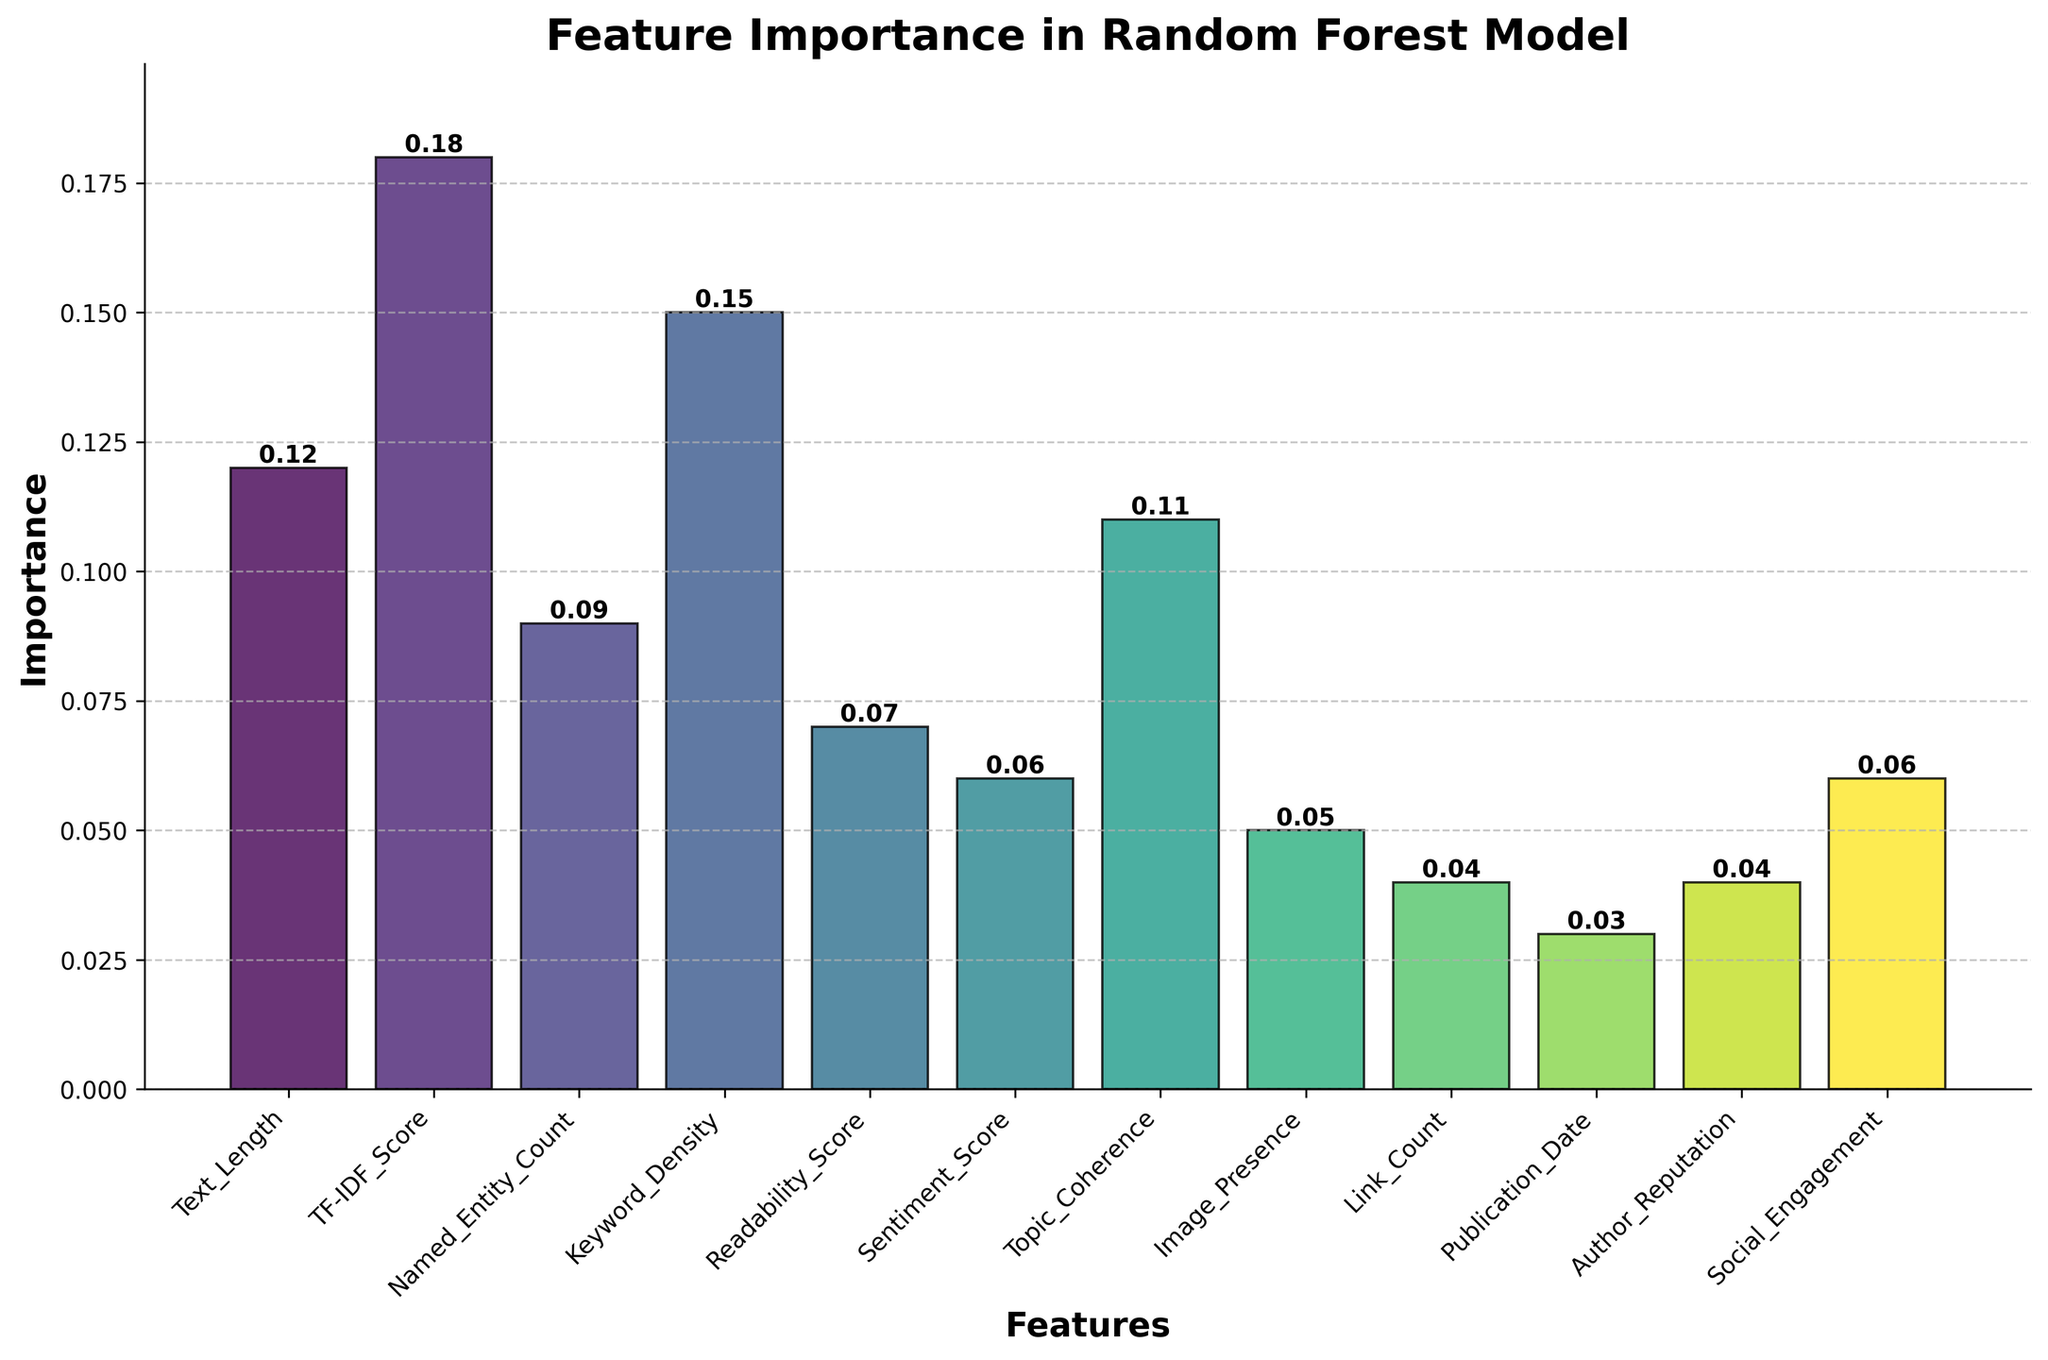What is the title of the figure? The title is typically found at the top of the figure and is usually large and bold compared to other text elements.
Answer: Feature Importance in Random Forest Model How many features have an importance value greater than 0.1? By observing the height of the bars, you can count the number of bars representing values greater than 0.1. These bars are for 'Text_Length', 'TF-IDF_Score', 'Keyword_Density', and 'Topic_Coherence'.
Answer: 4 Which feature has the highest importance value, and what is its value? Look at the height of all bars and identify the tallest one. The bar for 'TF-IDF_Score' is the tallest. Its height label reads 0.18.
Answer: TF-IDF_Score, 0.18 Is the importance of 'Readability_Score' greater than 'Sentiment_Score'? Compare the heights of the bars for 'Readability_Score' and 'Sentiment_Score'. The 'Readability_Score' bar is at 0.07, and the 'Sentiment_Score' bar is at 0.06.
Answer: Yes What is the combined importance value of the three least important features? Identify the bars with the smallest heights. 'Publication_Date', 'Link_Count', and 'Author_Reputation' are the least important with values 0.03, 0.04, and 0.04 respectively. Sum them: 0.03 + 0.04 + 0.04.
Answer: 0.11 What feature has an importance value of 0.05, and how does it visually compare to the next lowest value? Identify the feature labeled at 0.05, which is 'Image_Presence'. Visually, it is slightly taller than 'Publication_Date' which is at 0.03 and of similar height to 'Link_Count'.
Answer: Image_Presence Which two features share the same importance value of 0.06? Locate bars with the 0.06 label. Both 'Sentiment_Score' and 'Social_Engagement' have the same height indicating an importance of 0.06.
Answer: Sentiment_Score and Social_Engagement What is the average importance value of all features shown? Sum up all the importance values and divide by the number of features. The sum is 0.12 + 0.18 + 0.09 + 0.15 + 0.07 + 0.06 + 0.11 + 0.05 + 0.04 + 0.03 + 0.04 + 0.06 = 1.00. Dividing by the 12 features gives 1.00/12.
Answer: 0.083 What is the difference in importance values between the highest and lowest ranked features? Locate the highest bar ('TF-IDF_Score' at 0.18) and the lowest ('Publication_Date' at 0.03), then subtract the lowest from the highest: 0.18 - 0.03.
Answer: 0.15 